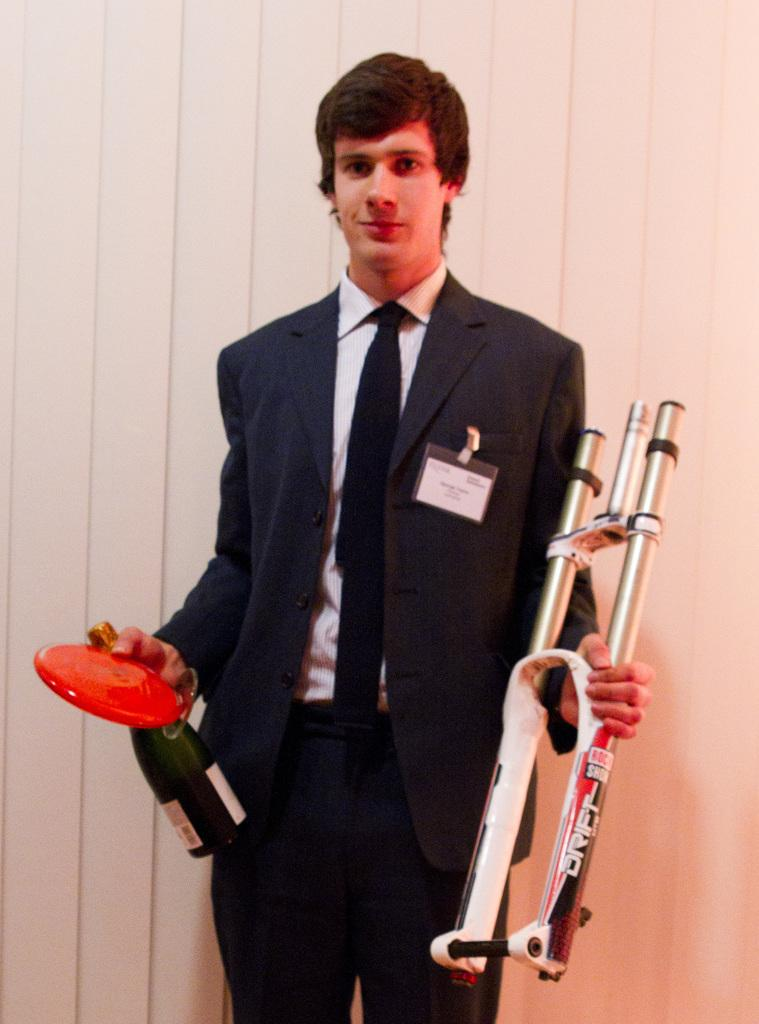Who or what is the main subject in the center of the picture? There is a person in the center of the picture. What is the person wearing? The person is wearing a black suit. What is the person holding in their hands? The person is holding a bottle and other objects. What can be seen behind the person? There is a window blind behind the person. Can you tell me how many cows are visible in the picture? There are no cows visible in the picture; the main subject is a person wearing a black suit. What type of rat is sitting on the person's shoulder in the picture? There is no rat present in the picture; the person is holding a bottle and other objects. 